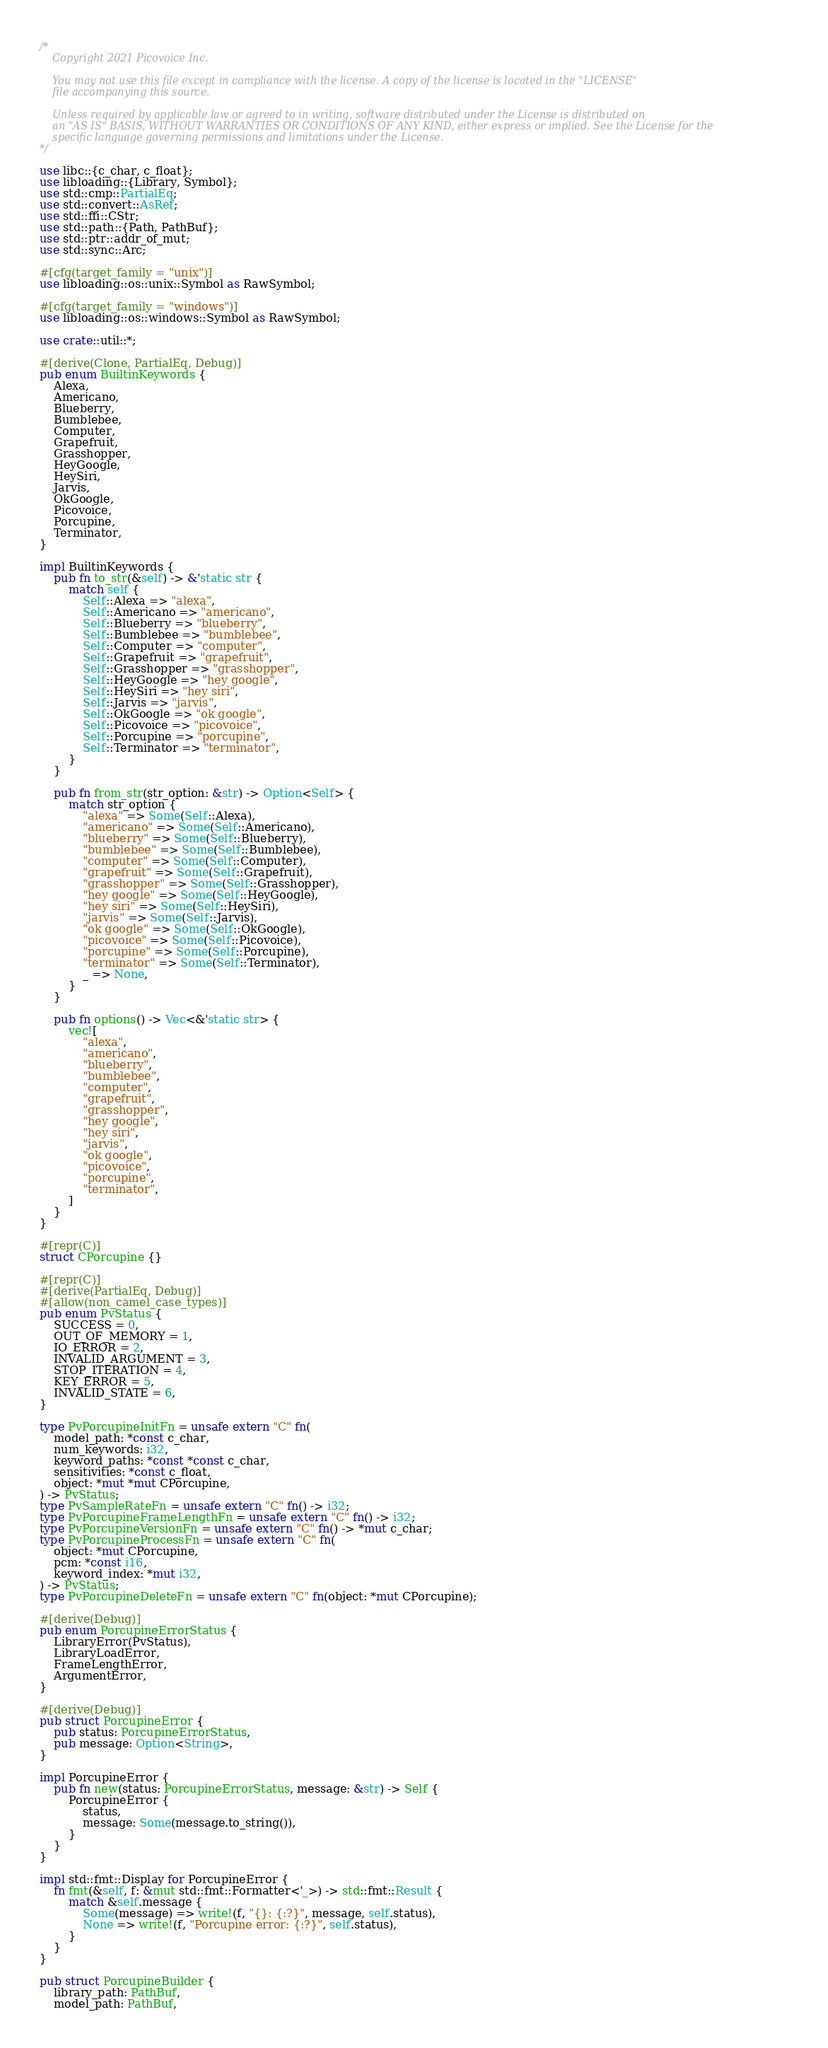Convert code to text. <code><loc_0><loc_0><loc_500><loc_500><_Rust_>/*
    Copyright 2021 Picovoice Inc.

    You may not use this file except in compliance with the license. A copy of the license is located in the "LICENSE"
    file accompanying this source.

    Unless required by applicable law or agreed to in writing, software distributed under the License is distributed on
    an "AS IS" BASIS, WITHOUT WARRANTIES OR CONDITIONS OF ANY KIND, either express or implied. See the License for the
    specific language governing permissions and limitations under the License.
*/

use libc::{c_char, c_float};
use libloading::{Library, Symbol};
use std::cmp::PartialEq;
use std::convert::AsRef;
use std::ffi::CStr;
use std::path::{Path, PathBuf};
use std::ptr::addr_of_mut;
use std::sync::Arc;

#[cfg(target_family = "unix")]
use libloading::os::unix::Symbol as RawSymbol;

#[cfg(target_family = "windows")]
use libloading::os::windows::Symbol as RawSymbol;

use crate::util::*;

#[derive(Clone, PartialEq, Debug)]
pub enum BuiltinKeywords {
    Alexa,
    Americano,
    Blueberry,
    Bumblebee,
    Computer,
    Grapefruit,
    Grasshopper,
    HeyGoogle,
    HeySiri,
    Jarvis,
    OkGoogle,
    Picovoice,
    Porcupine,
    Terminator,
}

impl BuiltinKeywords {
    pub fn to_str(&self) -> &'static str {
        match self {
            Self::Alexa => "alexa",
            Self::Americano => "americano",
            Self::Blueberry => "blueberry",
            Self::Bumblebee => "bumblebee",
            Self::Computer => "computer",
            Self::Grapefruit => "grapefruit",
            Self::Grasshopper => "grasshopper",
            Self::HeyGoogle => "hey google",
            Self::HeySiri => "hey siri",
            Self::Jarvis => "jarvis",
            Self::OkGoogle => "ok google",
            Self::Picovoice => "picovoice",
            Self::Porcupine => "porcupine",
            Self::Terminator => "terminator",
        }
    }

    pub fn from_str(str_option: &str) -> Option<Self> {
        match str_option {
            "alexa" => Some(Self::Alexa),
            "americano" => Some(Self::Americano),
            "blueberry" => Some(Self::Blueberry),
            "bumblebee" => Some(Self::Bumblebee),
            "computer" => Some(Self::Computer),
            "grapefruit" => Some(Self::Grapefruit),
            "grasshopper" => Some(Self::Grasshopper),
            "hey google" => Some(Self::HeyGoogle),
            "hey siri" => Some(Self::HeySiri),
            "jarvis" => Some(Self::Jarvis),
            "ok google" => Some(Self::OkGoogle),
            "picovoice" => Some(Self::Picovoice),
            "porcupine" => Some(Self::Porcupine),
            "terminator" => Some(Self::Terminator),
            _ => None,
        }
    }

    pub fn options() -> Vec<&'static str> {
        vec![
            "alexa",
            "americano",
            "blueberry",
            "bumblebee",
            "computer",
            "grapefruit",
            "grasshopper",
            "hey google",
            "hey siri",
            "jarvis",
            "ok google",
            "picovoice",
            "porcupine",
            "terminator",
        ]
    }
}

#[repr(C)]
struct CPorcupine {}

#[repr(C)]
#[derive(PartialEq, Debug)]
#[allow(non_camel_case_types)]
pub enum PvStatus {
    SUCCESS = 0,
    OUT_OF_MEMORY = 1,
    IO_ERROR = 2,
    INVALID_ARGUMENT = 3,
    STOP_ITERATION = 4,
    KEY_ERROR = 5,
    INVALID_STATE = 6,
}

type PvPorcupineInitFn = unsafe extern "C" fn(
    model_path: *const c_char,
    num_keywords: i32,
    keyword_paths: *const *const c_char,
    sensitivities: *const c_float,
    object: *mut *mut CPorcupine,
) -> PvStatus;
type PvSampleRateFn = unsafe extern "C" fn() -> i32;
type PvPorcupineFrameLengthFn = unsafe extern "C" fn() -> i32;
type PvPorcupineVersionFn = unsafe extern "C" fn() -> *mut c_char;
type PvPorcupineProcessFn = unsafe extern "C" fn(
    object: *mut CPorcupine,
    pcm: *const i16,
    keyword_index: *mut i32,
) -> PvStatus;
type PvPorcupineDeleteFn = unsafe extern "C" fn(object: *mut CPorcupine);

#[derive(Debug)]
pub enum PorcupineErrorStatus {
    LibraryError(PvStatus),
    LibraryLoadError,
    FrameLengthError,
    ArgumentError,
}

#[derive(Debug)]
pub struct PorcupineError {
    pub status: PorcupineErrorStatus,
    pub message: Option<String>,
}

impl PorcupineError {
    pub fn new(status: PorcupineErrorStatus, message: &str) -> Self {
        PorcupineError {
            status,
            message: Some(message.to_string()),
        }
    }
}

impl std::fmt::Display for PorcupineError {
    fn fmt(&self, f: &mut std::fmt::Formatter<'_>) -> std::fmt::Result {
        match &self.message {
            Some(message) => write!(f, "{}: {:?}", message, self.status),
            None => write!(f, "Porcupine error: {:?}", self.status),
        }
    }
}

pub struct PorcupineBuilder {
    library_path: PathBuf,
    model_path: PathBuf,</code> 